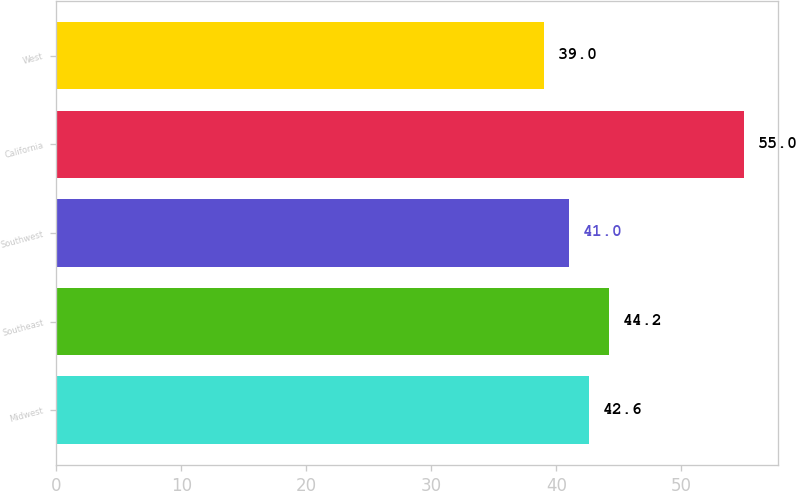<chart> <loc_0><loc_0><loc_500><loc_500><bar_chart><fcel>Midwest<fcel>Southeast<fcel>Southwest<fcel>California<fcel>West<nl><fcel>42.6<fcel>44.2<fcel>41<fcel>55<fcel>39<nl></chart> 